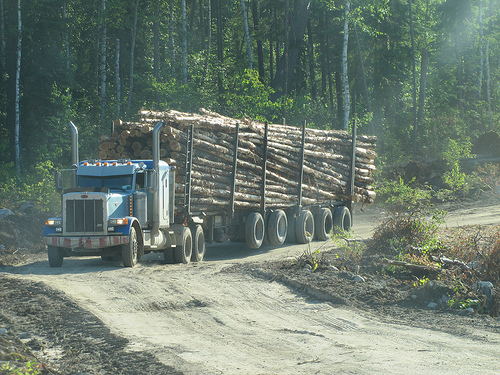<image>
Is the vehicle next to the wood? No. The vehicle is not positioned next to the wood. They are located in different areas of the scene. 